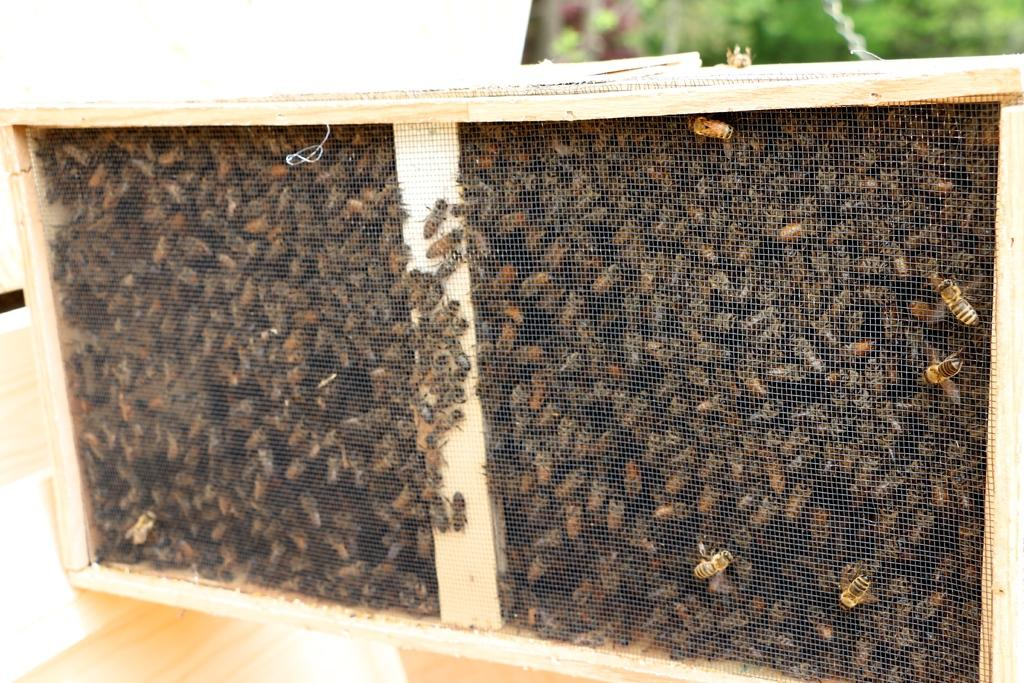What object is present in the image that is made of wood? There is a wooden box in the image. What is inside the wooden box? The wooden box is full of honey bees. What type of vegetation can be seen in the background of the image? There are green plants visible in the background of the image. How many hands are visible in the image? There are no hands visible in the image. What type of net is being used to catch the flock of birds in the image? There are no birds or nets present in the image. 